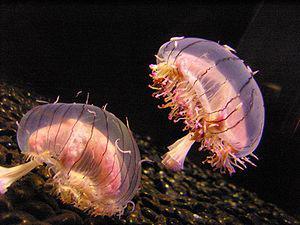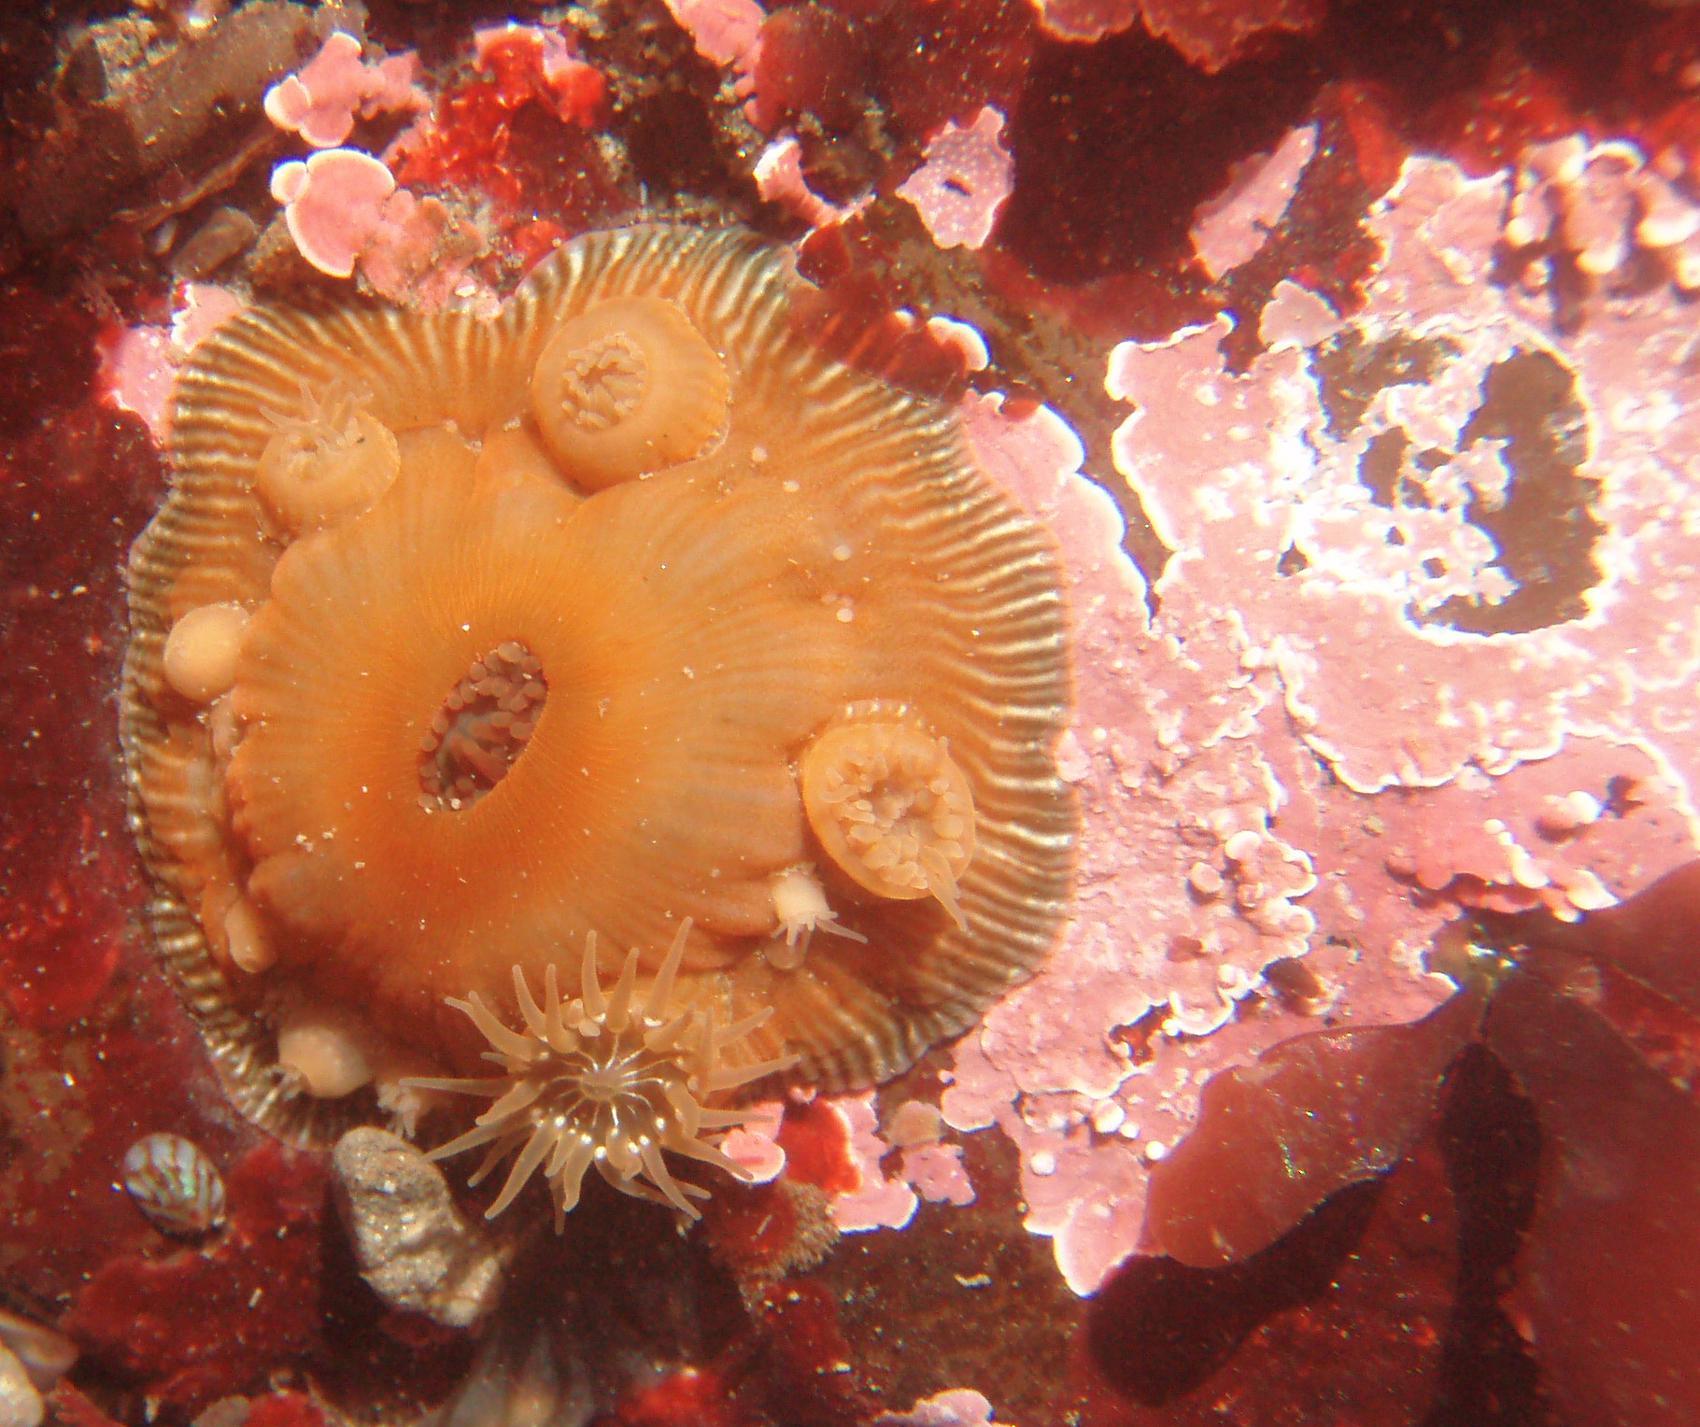The first image is the image on the left, the second image is the image on the right. Examine the images to the left and right. Is the description "Left image shows at least five of the same type of anemones with pale tendrils." accurate? Answer yes or no. No. 